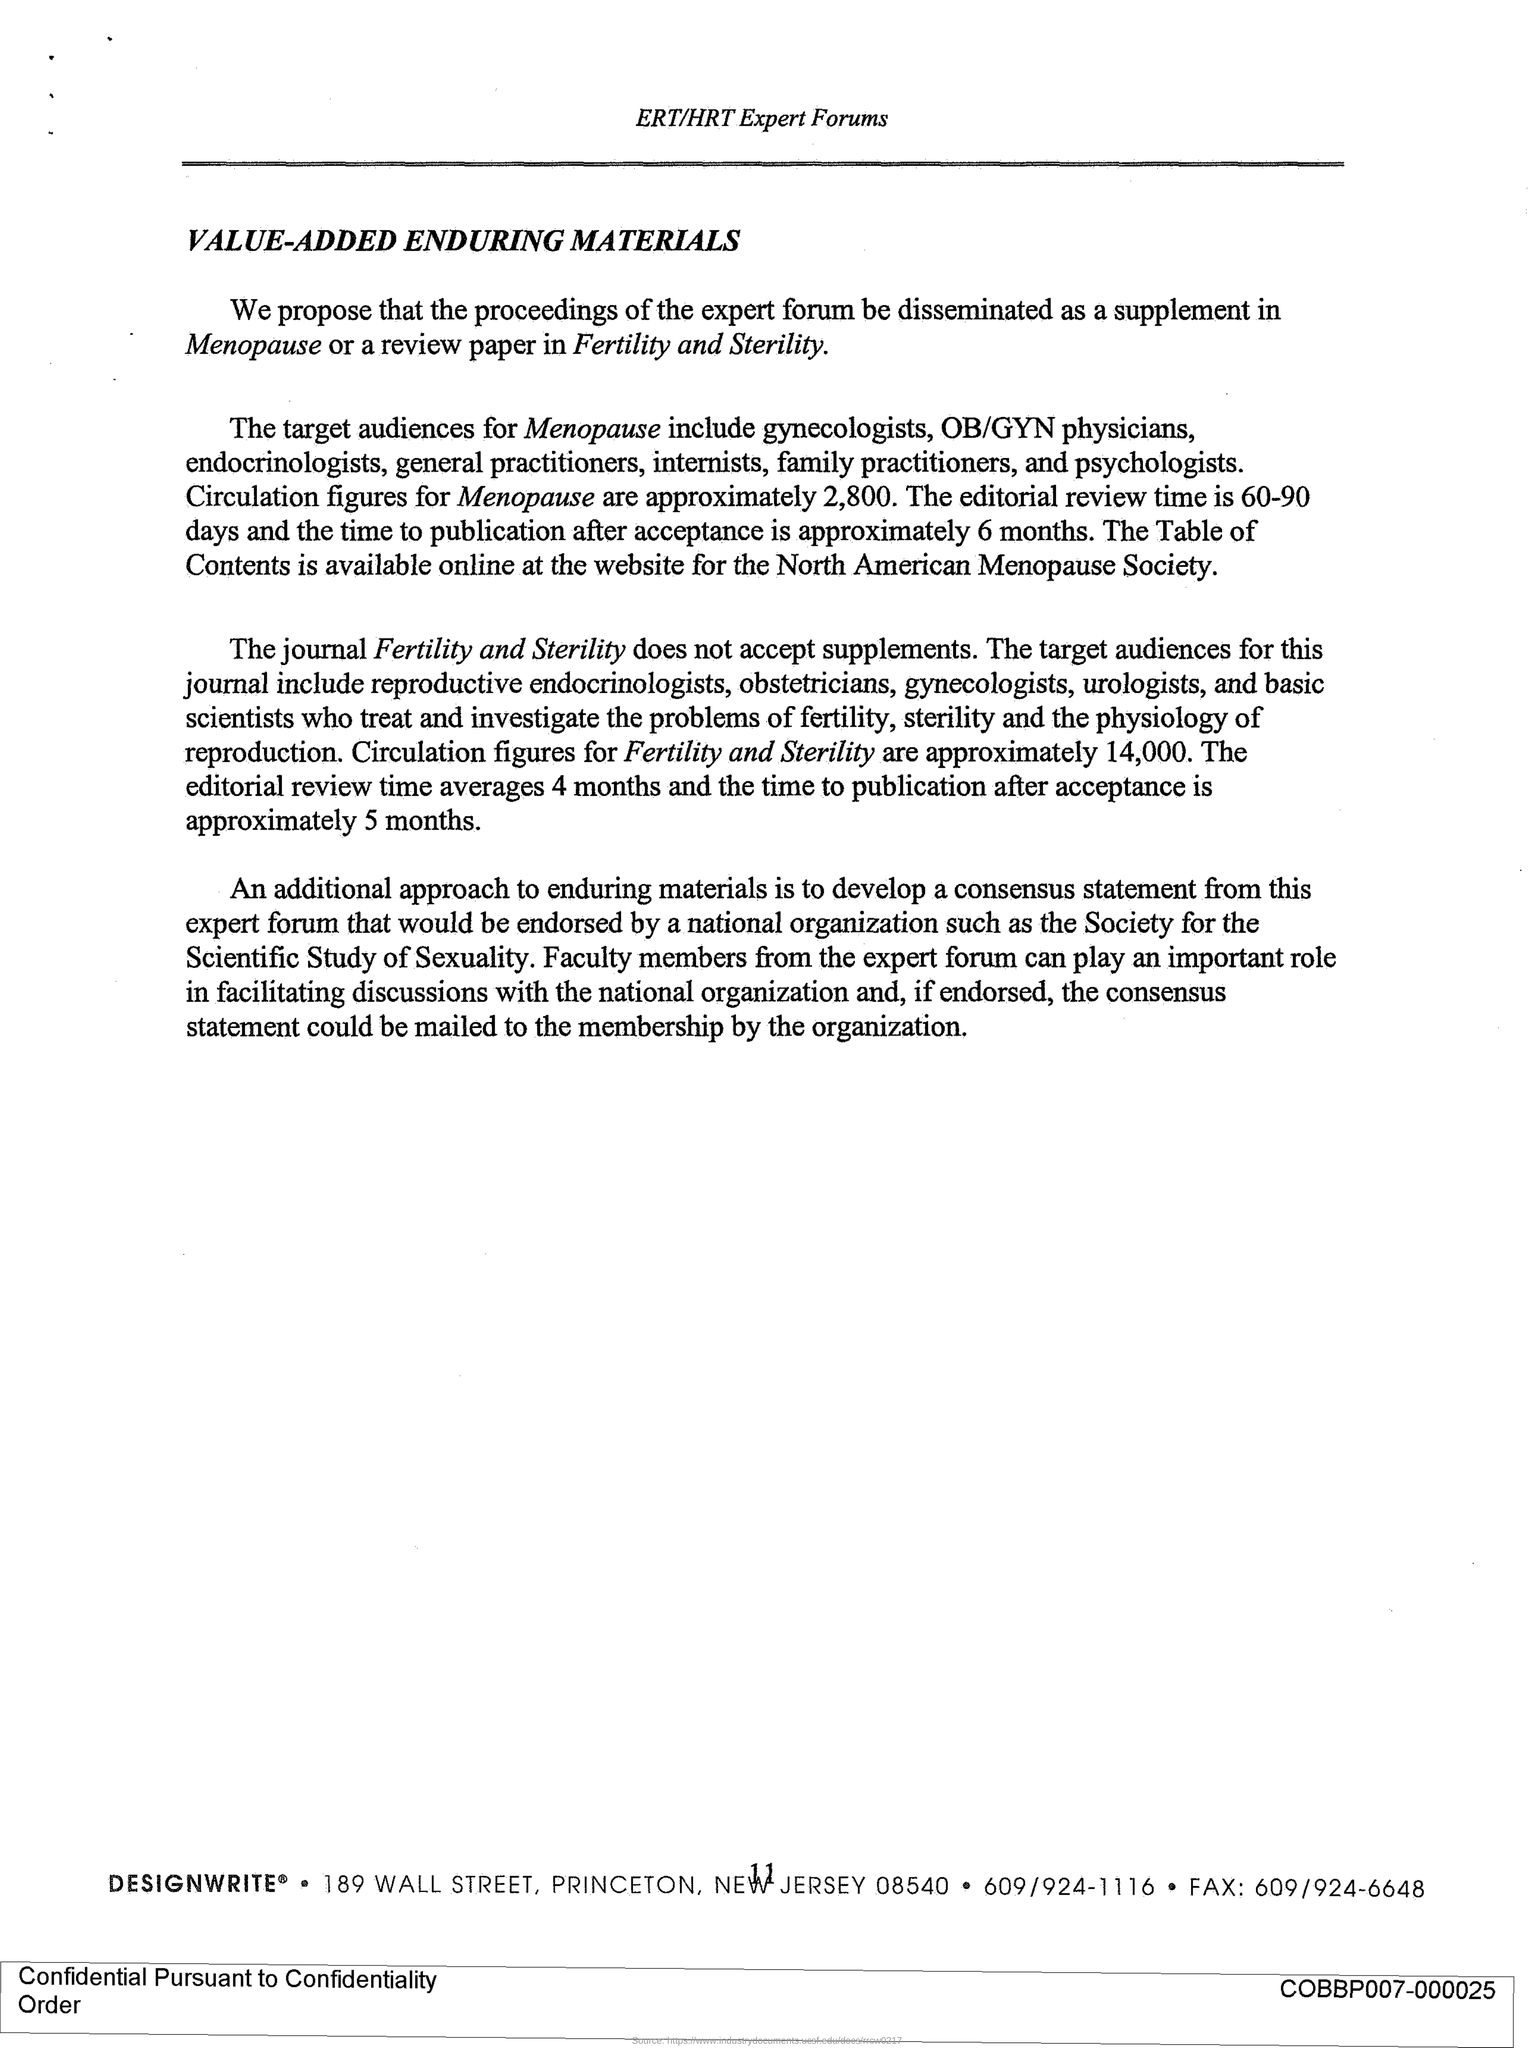Which journal does not accept supplements?
Give a very brief answer. Fertility and Sterility. What are the circulation figures for the journal Fertility and Sterility?
Give a very brief answer. Approximately 14,000. What is the title of this document?
Provide a short and direct response. Value-Added Enduring Materials. Which forum is mentioned in the header of the document?
Make the answer very short. ERT/HRT Expert Forums. 